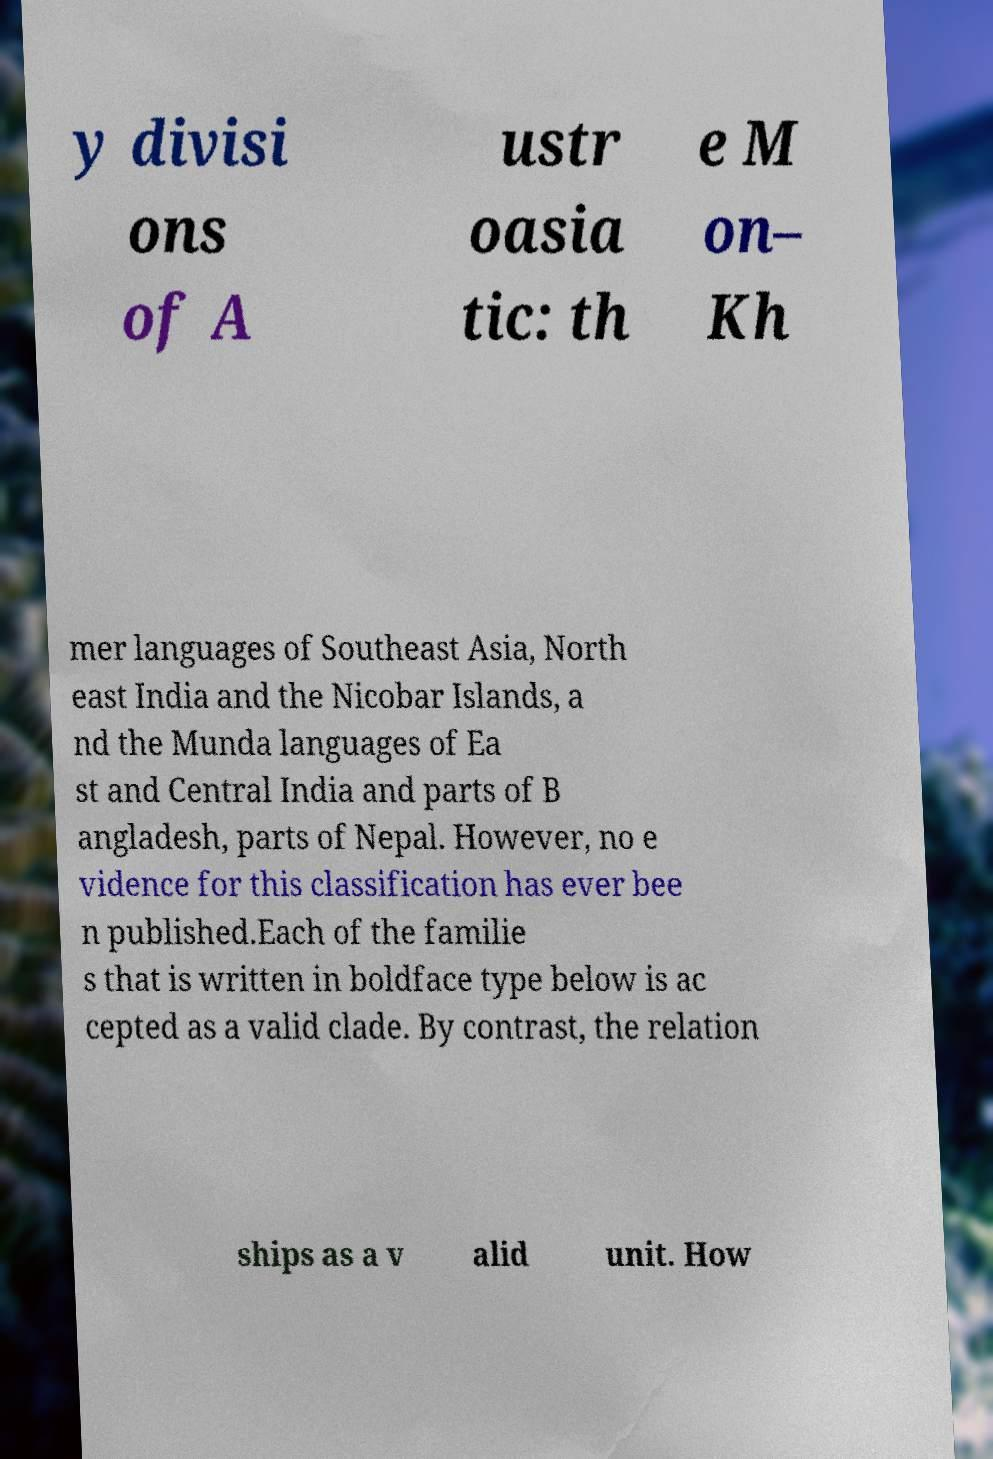Could you extract and type out the text from this image? y divisi ons of A ustr oasia tic: th e M on– Kh mer languages of Southeast Asia, North east India and the Nicobar Islands, a nd the Munda languages of Ea st and Central India and parts of B angladesh, parts of Nepal. However, no e vidence for this classification has ever bee n published.Each of the familie s that is written in boldface type below is ac cepted as a valid clade. By contrast, the relation ships as a v alid unit. How 